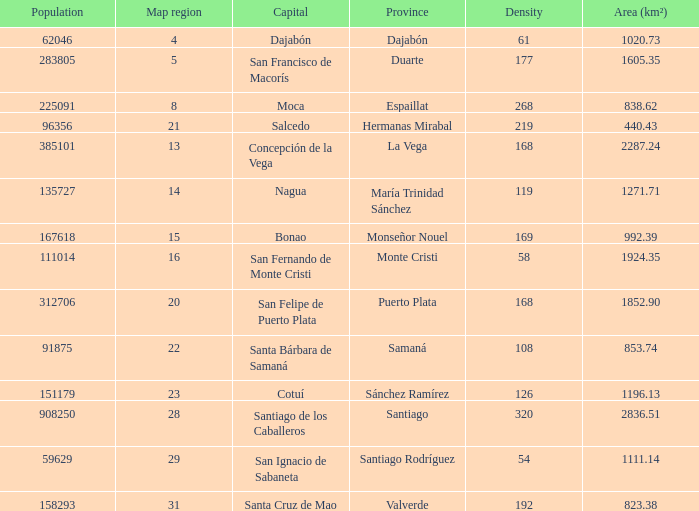Nagua has the area (km²) of? 1271.71. 